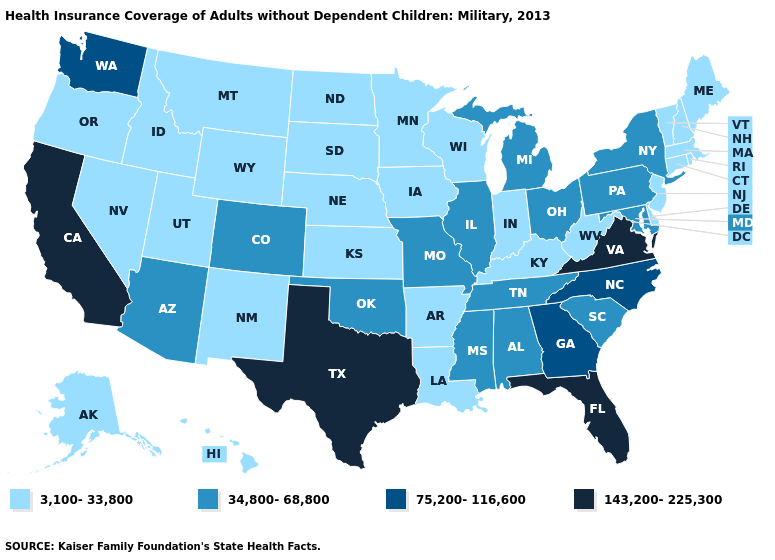Does Michigan have the highest value in the MidWest?
Give a very brief answer. Yes. What is the value of Colorado?
Give a very brief answer. 34,800-68,800. What is the lowest value in states that border Florida?
Give a very brief answer. 34,800-68,800. What is the value of Missouri?
Short answer required. 34,800-68,800. Among the states that border Washington , which have the highest value?
Be succinct. Idaho, Oregon. What is the value of Oregon?
Write a very short answer. 3,100-33,800. Which states have the lowest value in the USA?
Be succinct. Alaska, Arkansas, Connecticut, Delaware, Hawaii, Idaho, Indiana, Iowa, Kansas, Kentucky, Louisiana, Maine, Massachusetts, Minnesota, Montana, Nebraska, Nevada, New Hampshire, New Jersey, New Mexico, North Dakota, Oregon, Rhode Island, South Dakota, Utah, Vermont, West Virginia, Wisconsin, Wyoming. What is the value of Montana?
Short answer required. 3,100-33,800. Among the states that border North Carolina , does Virginia have the highest value?
Keep it brief. Yes. Does Florida have the highest value in the USA?
Quick response, please. Yes. Name the states that have a value in the range 75,200-116,600?
Answer briefly. Georgia, North Carolina, Washington. Name the states that have a value in the range 143,200-225,300?
Concise answer only. California, Florida, Texas, Virginia. How many symbols are there in the legend?
Write a very short answer. 4. Name the states that have a value in the range 3,100-33,800?
Be succinct. Alaska, Arkansas, Connecticut, Delaware, Hawaii, Idaho, Indiana, Iowa, Kansas, Kentucky, Louisiana, Maine, Massachusetts, Minnesota, Montana, Nebraska, Nevada, New Hampshire, New Jersey, New Mexico, North Dakota, Oregon, Rhode Island, South Dakota, Utah, Vermont, West Virginia, Wisconsin, Wyoming. Does Arizona have the lowest value in the West?
Answer briefly. No. 